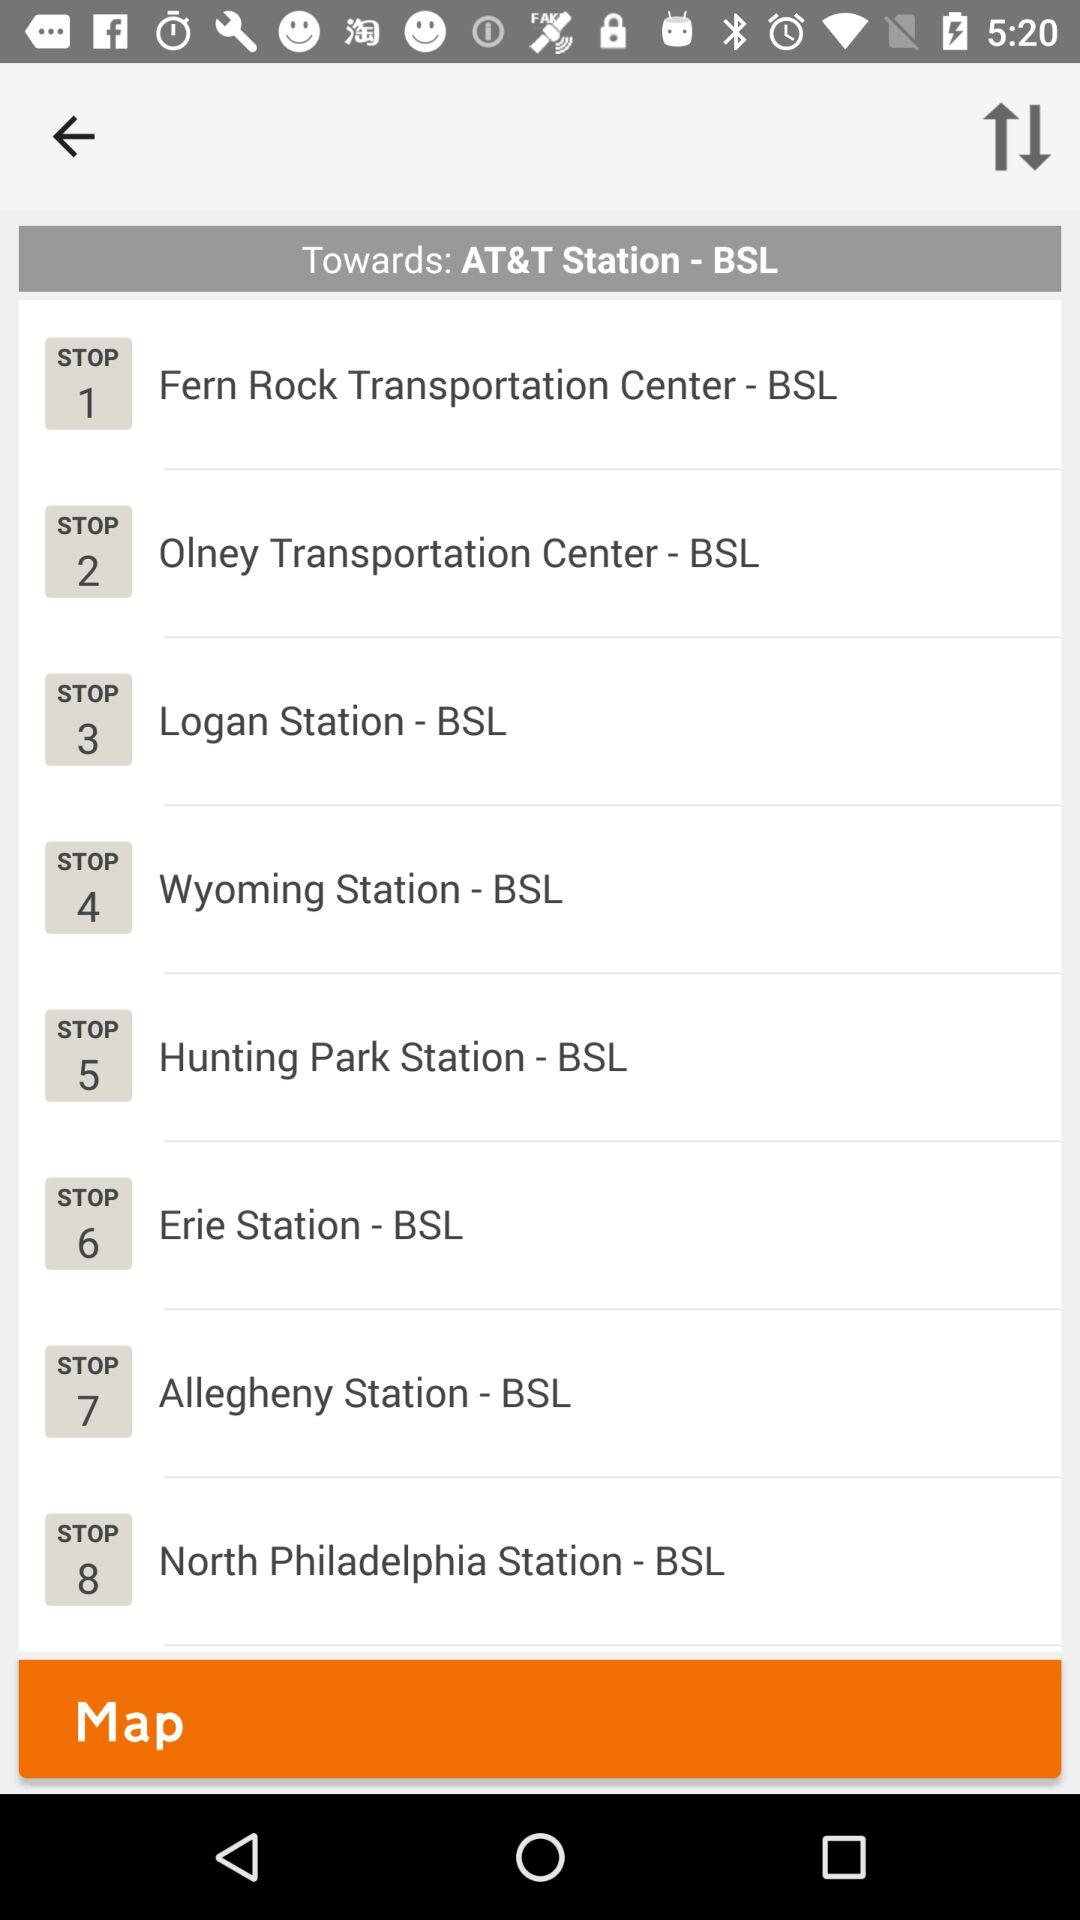How many stops are there on the BSL?
Answer the question using a single word or phrase. 8 